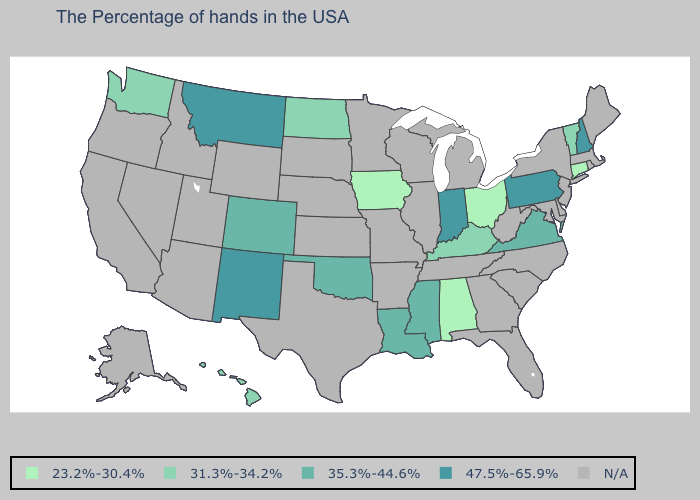What is the value of New York?
Keep it brief. N/A. Does Washington have the lowest value in the West?
Keep it brief. Yes. What is the value of North Dakota?
Give a very brief answer. 31.3%-34.2%. Which states have the lowest value in the USA?
Be succinct. Connecticut, Ohio, Alabama, Iowa. Name the states that have a value in the range 35.3%-44.6%?
Be succinct. Virginia, Mississippi, Louisiana, Oklahoma, Colorado. What is the highest value in states that border Pennsylvania?
Short answer required. 23.2%-30.4%. What is the lowest value in states that border South Dakota?
Keep it brief. 23.2%-30.4%. What is the lowest value in the USA?
Write a very short answer. 23.2%-30.4%. Name the states that have a value in the range 47.5%-65.9%?
Quick response, please. New Hampshire, Pennsylvania, Indiana, New Mexico, Montana. Name the states that have a value in the range 47.5%-65.9%?
Concise answer only. New Hampshire, Pennsylvania, Indiana, New Mexico, Montana. Does the map have missing data?
Concise answer only. Yes. Name the states that have a value in the range 35.3%-44.6%?
Be succinct. Virginia, Mississippi, Louisiana, Oklahoma, Colorado. Does the map have missing data?
Keep it brief. Yes. 